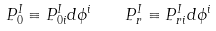<formula> <loc_0><loc_0><loc_500><loc_500>P ^ { I } _ { 0 } \equiv P ^ { I } _ { 0 i } d \phi ^ { i } \quad P ^ { I } _ { r } \equiv P ^ { I } _ { r i } d \phi ^ { i }</formula> 